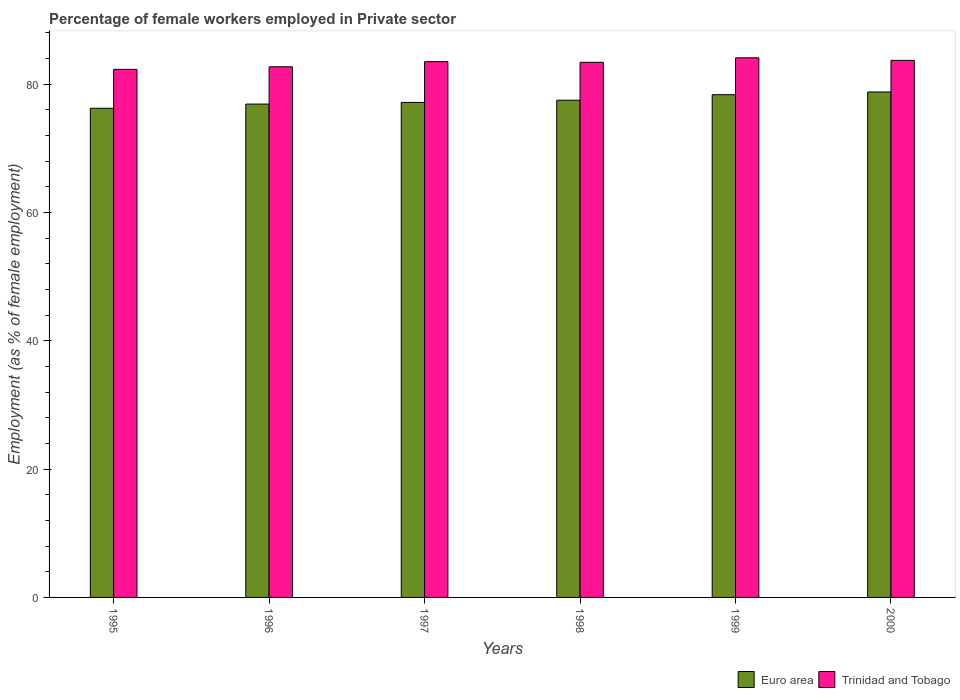How many different coloured bars are there?
Keep it short and to the point. 2. How many bars are there on the 4th tick from the left?
Your answer should be very brief. 2. How many bars are there on the 2nd tick from the right?
Ensure brevity in your answer.  2. In how many cases, is the number of bars for a given year not equal to the number of legend labels?
Offer a very short reply. 0. What is the percentage of females employed in Private sector in Trinidad and Tobago in 1999?
Offer a very short reply. 84.1. Across all years, what is the maximum percentage of females employed in Private sector in Euro area?
Give a very brief answer. 78.77. Across all years, what is the minimum percentage of females employed in Private sector in Euro area?
Your response must be concise. 76.23. What is the total percentage of females employed in Private sector in Trinidad and Tobago in the graph?
Ensure brevity in your answer.  499.7. What is the difference between the percentage of females employed in Private sector in Euro area in 1996 and that in 2000?
Your answer should be compact. -1.88. What is the difference between the percentage of females employed in Private sector in Trinidad and Tobago in 1998 and the percentage of females employed in Private sector in Euro area in 1997?
Ensure brevity in your answer.  6.25. What is the average percentage of females employed in Private sector in Trinidad and Tobago per year?
Ensure brevity in your answer.  83.28. In the year 1995, what is the difference between the percentage of females employed in Private sector in Euro area and percentage of females employed in Private sector in Trinidad and Tobago?
Keep it short and to the point. -6.07. In how many years, is the percentage of females employed in Private sector in Euro area greater than 52 %?
Make the answer very short. 6. What is the ratio of the percentage of females employed in Private sector in Euro area in 1998 to that in 2000?
Offer a terse response. 0.98. Is the difference between the percentage of females employed in Private sector in Euro area in 1995 and 1997 greater than the difference between the percentage of females employed in Private sector in Trinidad and Tobago in 1995 and 1997?
Offer a very short reply. Yes. What is the difference between the highest and the second highest percentage of females employed in Private sector in Euro area?
Give a very brief answer. 0.42. What is the difference between the highest and the lowest percentage of females employed in Private sector in Trinidad and Tobago?
Make the answer very short. 1.8. In how many years, is the percentage of females employed in Private sector in Trinidad and Tobago greater than the average percentage of females employed in Private sector in Trinidad and Tobago taken over all years?
Ensure brevity in your answer.  4. Is the sum of the percentage of females employed in Private sector in Euro area in 1996 and 1997 greater than the maximum percentage of females employed in Private sector in Trinidad and Tobago across all years?
Your answer should be compact. Yes. What does the 1st bar from the right in 1997 represents?
Offer a very short reply. Trinidad and Tobago. What is the difference between two consecutive major ticks on the Y-axis?
Offer a very short reply. 20. Does the graph contain any zero values?
Your answer should be very brief. No. What is the title of the graph?
Make the answer very short. Percentage of female workers employed in Private sector. Does "Italy" appear as one of the legend labels in the graph?
Your response must be concise. No. What is the label or title of the X-axis?
Provide a short and direct response. Years. What is the label or title of the Y-axis?
Your answer should be very brief. Employment (as % of female employment). What is the Employment (as % of female employment) of Euro area in 1995?
Keep it short and to the point. 76.23. What is the Employment (as % of female employment) in Trinidad and Tobago in 1995?
Provide a succinct answer. 82.3. What is the Employment (as % of female employment) in Euro area in 1996?
Provide a short and direct response. 76.89. What is the Employment (as % of female employment) in Trinidad and Tobago in 1996?
Your answer should be very brief. 82.7. What is the Employment (as % of female employment) in Euro area in 1997?
Keep it short and to the point. 77.15. What is the Employment (as % of female employment) of Trinidad and Tobago in 1997?
Offer a terse response. 83.5. What is the Employment (as % of female employment) in Euro area in 1998?
Provide a succinct answer. 77.49. What is the Employment (as % of female employment) of Trinidad and Tobago in 1998?
Keep it short and to the point. 83.4. What is the Employment (as % of female employment) in Euro area in 1999?
Ensure brevity in your answer.  78.35. What is the Employment (as % of female employment) in Trinidad and Tobago in 1999?
Offer a very short reply. 84.1. What is the Employment (as % of female employment) in Euro area in 2000?
Your answer should be compact. 78.77. What is the Employment (as % of female employment) of Trinidad and Tobago in 2000?
Keep it short and to the point. 83.7. Across all years, what is the maximum Employment (as % of female employment) in Euro area?
Ensure brevity in your answer.  78.77. Across all years, what is the maximum Employment (as % of female employment) in Trinidad and Tobago?
Make the answer very short. 84.1. Across all years, what is the minimum Employment (as % of female employment) in Euro area?
Provide a succinct answer. 76.23. Across all years, what is the minimum Employment (as % of female employment) in Trinidad and Tobago?
Give a very brief answer. 82.3. What is the total Employment (as % of female employment) in Euro area in the graph?
Provide a short and direct response. 464.89. What is the total Employment (as % of female employment) of Trinidad and Tobago in the graph?
Your answer should be compact. 499.7. What is the difference between the Employment (as % of female employment) of Euro area in 1995 and that in 1996?
Provide a succinct answer. -0.66. What is the difference between the Employment (as % of female employment) in Trinidad and Tobago in 1995 and that in 1996?
Your answer should be very brief. -0.4. What is the difference between the Employment (as % of female employment) of Euro area in 1995 and that in 1997?
Your response must be concise. -0.91. What is the difference between the Employment (as % of female employment) in Trinidad and Tobago in 1995 and that in 1997?
Make the answer very short. -1.2. What is the difference between the Employment (as % of female employment) of Euro area in 1995 and that in 1998?
Offer a very short reply. -1.26. What is the difference between the Employment (as % of female employment) in Euro area in 1995 and that in 1999?
Your response must be concise. -2.12. What is the difference between the Employment (as % of female employment) in Euro area in 1995 and that in 2000?
Offer a terse response. -2.54. What is the difference between the Employment (as % of female employment) in Euro area in 1996 and that in 1997?
Ensure brevity in your answer.  -0.26. What is the difference between the Employment (as % of female employment) of Trinidad and Tobago in 1996 and that in 1997?
Provide a short and direct response. -0.8. What is the difference between the Employment (as % of female employment) of Euro area in 1996 and that in 1998?
Offer a terse response. -0.6. What is the difference between the Employment (as % of female employment) of Euro area in 1996 and that in 1999?
Keep it short and to the point. -1.46. What is the difference between the Employment (as % of female employment) of Euro area in 1996 and that in 2000?
Offer a terse response. -1.88. What is the difference between the Employment (as % of female employment) in Trinidad and Tobago in 1996 and that in 2000?
Keep it short and to the point. -1. What is the difference between the Employment (as % of female employment) in Euro area in 1997 and that in 1998?
Your response must be concise. -0.35. What is the difference between the Employment (as % of female employment) in Trinidad and Tobago in 1997 and that in 1998?
Give a very brief answer. 0.1. What is the difference between the Employment (as % of female employment) in Euro area in 1997 and that in 1999?
Your answer should be compact. -1.21. What is the difference between the Employment (as % of female employment) in Trinidad and Tobago in 1997 and that in 1999?
Provide a succinct answer. -0.6. What is the difference between the Employment (as % of female employment) of Euro area in 1997 and that in 2000?
Provide a short and direct response. -1.63. What is the difference between the Employment (as % of female employment) in Trinidad and Tobago in 1997 and that in 2000?
Your answer should be compact. -0.2. What is the difference between the Employment (as % of female employment) of Euro area in 1998 and that in 1999?
Offer a very short reply. -0.86. What is the difference between the Employment (as % of female employment) in Euro area in 1998 and that in 2000?
Your answer should be compact. -1.28. What is the difference between the Employment (as % of female employment) in Euro area in 1999 and that in 2000?
Make the answer very short. -0.42. What is the difference between the Employment (as % of female employment) in Trinidad and Tobago in 1999 and that in 2000?
Your answer should be very brief. 0.4. What is the difference between the Employment (as % of female employment) in Euro area in 1995 and the Employment (as % of female employment) in Trinidad and Tobago in 1996?
Give a very brief answer. -6.47. What is the difference between the Employment (as % of female employment) in Euro area in 1995 and the Employment (as % of female employment) in Trinidad and Tobago in 1997?
Give a very brief answer. -7.27. What is the difference between the Employment (as % of female employment) in Euro area in 1995 and the Employment (as % of female employment) in Trinidad and Tobago in 1998?
Make the answer very short. -7.17. What is the difference between the Employment (as % of female employment) of Euro area in 1995 and the Employment (as % of female employment) of Trinidad and Tobago in 1999?
Keep it short and to the point. -7.87. What is the difference between the Employment (as % of female employment) of Euro area in 1995 and the Employment (as % of female employment) of Trinidad and Tobago in 2000?
Offer a terse response. -7.47. What is the difference between the Employment (as % of female employment) of Euro area in 1996 and the Employment (as % of female employment) of Trinidad and Tobago in 1997?
Your answer should be compact. -6.61. What is the difference between the Employment (as % of female employment) of Euro area in 1996 and the Employment (as % of female employment) of Trinidad and Tobago in 1998?
Your response must be concise. -6.51. What is the difference between the Employment (as % of female employment) in Euro area in 1996 and the Employment (as % of female employment) in Trinidad and Tobago in 1999?
Offer a terse response. -7.21. What is the difference between the Employment (as % of female employment) of Euro area in 1996 and the Employment (as % of female employment) of Trinidad and Tobago in 2000?
Offer a terse response. -6.81. What is the difference between the Employment (as % of female employment) of Euro area in 1997 and the Employment (as % of female employment) of Trinidad and Tobago in 1998?
Your answer should be compact. -6.25. What is the difference between the Employment (as % of female employment) of Euro area in 1997 and the Employment (as % of female employment) of Trinidad and Tobago in 1999?
Provide a short and direct response. -6.95. What is the difference between the Employment (as % of female employment) in Euro area in 1997 and the Employment (as % of female employment) in Trinidad and Tobago in 2000?
Provide a short and direct response. -6.55. What is the difference between the Employment (as % of female employment) in Euro area in 1998 and the Employment (as % of female employment) in Trinidad and Tobago in 1999?
Your response must be concise. -6.61. What is the difference between the Employment (as % of female employment) in Euro area in 1998 and the Employment (as % of female employment) in Trinidad and Tobago in 2000?
Offer a terse response. -6.21. What is the difference between the Employment (as % of female employment) in Euro area in 1999 and the Employment (as % of female employment) in Trinidad and Tobago in 2000?
Your answer should be very brief. -5.35. What is the average Employment (as % of female employment) in Euro area per year?
Give a very brief answer. 77.48. What is the average Employment (as % of female employment) of Trinidad and Tobago per year?
Provide a short and direct response. 83.28. In the year 1995, what is the difference between the Employment (as % of female employment) in Euro area and Employment (as % of female employment) in Trinidad and Tobago?
Keep it short and to the point. -6.07. In the year 1996, what is the difference between the Employment (as % of female employment) of Euro area and Employment (as % of female employment) of Trinidad and Tobago?
Your answer should be compact. -5.81. In the year 1997, what is the difference between the Employment (as % of female employment) of Euro area and Employment (as % of female employment) of Trinidad and Tobago?
Make the answer very short. -6.35. In the year 1998, what is the difference between the Employment (as % of female employment) of Euro area and Employment (as % of female employment) of Trinidad and Tobago?
Your answer should be very brief. -5.91. In the year 1999, what is the difference between the Employment (as % of female employment) of Euro area and Employment (as % of female employment) of Trinidad and Tobago?
Offer a terse response. -5.75. In the year 2000, what is the difference between the Employment (as % of female employment) of Euro area and Employment (as % of female employment) of Trinidad and Tobago?
Offer a very short reply. -4.93. What is the ratio of the Employment (as % of female employment) of Euro area in 1995 to that in 1996?
Keep it short and to the point. 0.99. What is the ratio of the Employment (as % of female employment) of Trinidad and Tobago in 1995 to that in 1997?
Provide a succinct answer. 0.99. What is the ratio of the Employment (as % of female employment) in Euro area in 1995 to that in 1998?
Ensure brevity in your answer.  0.98. What is the ratio of the Employment (as % of female employment) in Trinidad and Tobago in 1995 to that in 1998?
Keep it short and to the point. 0.99. What is the ratio of the Employment (as % of female employment) in Euro area in 1995 to that in 1999?
Provide a short and direct response. 0.97. What is the ratio of the Employment (as % of female employment) of Trinidad and Tobago in 1995 to that in 1999?
Your answer should be very brief. 0.98. What is the ratio of the Employment (as % of female employment) in Euro area in 1995 to that in 2000?
Give a very brief answer. 0.97. What is the ratio of the Employment (as % of female employment) in Trinidad and Tobago in 1995 to that in 2000?
Ensure brevity in your answer.  0.98. What is the ratio of the Employment (as % of female employment) in Euro area in 1996 to that in 1997?
Keep it short and to the point. 1. What is the ratio of the Employment (as % of female employment) in Trinidad and Tobago in 1996 to that in 1997?
Offer a terse response. 0.99. What is the ratio of the Employment (as % of female employment) in Trinidad and Tobago in 1996 to that in 1998?
Your response must be concise. 0.99. What is the ratio of the Employment (as % of female employment) in Euro area in 1996 to that in 1999?
Your answer should be compact. 0.98. What is the ratio of the Employment (as % of female employment) of Trinidad and Tobago in 1996 to that in 1999?
Provide a short and direct response. 0.98. What is the ratio of the Employment (as % of female employment) in Euro area in 1996 to that in 2000?
Give a very brief answer. 0.98. What is the ratio of the Employment (as % of female employment) of Trinidad and Tobago in 1996 to that in 2000?
Provide a succinct answer. 0.99. What is the ratio of the Employment (as % of female employment) in Trinidad and Tobago in 1997 to that in 1998?
Keep it short and to the point. 1. What is the ratio of the Employment (as % of female employment) of Euro area in 1997 to that in 1999?
Provide a short and direct response. 0.98. What is the ratio of the Employment (as % of female employment) in Trinidad and Tobago in 1997 to that in 1999?
Provide a short and direct response. 0.99. What is the ratio of the Employment (as % of female employment) in Euro area in 1997 to that in 2000?
Your answer should be compact. 0.98. What is the ratio of the Employment (as % of female employment) in Trinidad and Tobago in 1997 to that in 2000?
Ensure brevity in your answer.  1. What is the ratio of the Employment (as % of female employment) of Euro area in 1998 to that in 2000?
Give a very brief answer. 0.98. What is the ratio of the Employment (as % of female employment) of Euro area in 1999 to that in 2000?
Provide a succinct answer. 0.99. What is the difference between the highest and the second highest Employment (as % of female employment) in Euro area?
Keep it short and to the point. 0.42. What is the difference between the highest and the second highest Employment (as % of female employment) of Trinidad and Tobago?
Make the answer very short. 0.4. What is the difference between the highest and the lowest Employment (as % of female employment) in Euro area?
Provide a succinct answer. 2.54. What is the difference between the highest and the lowest Employment (as % of female employment) in Trinidad and Tobago?
Give a very brief answer. 1.8. 